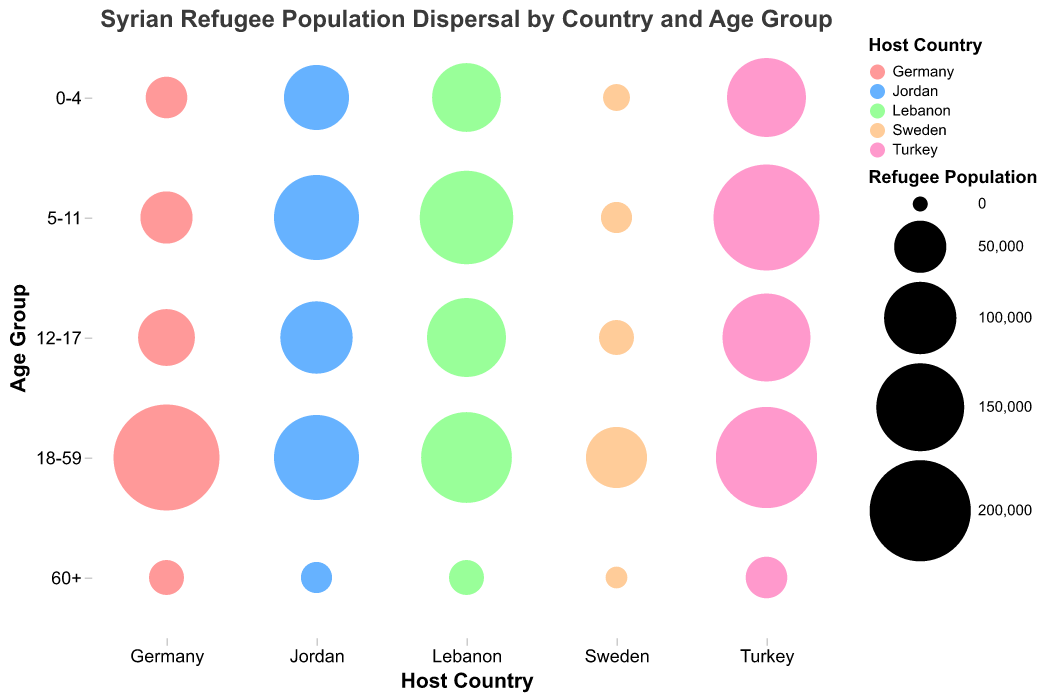What is the host country with the largest refugee population from Syria in the 18-59 age group? Observing the bubble chart, the largest bubble in the 18-59 age group is in Germany.
Answer: Germany Which age group has the smallest refugee population in Sweden? Referring to the smallest bubble in Sweden, the 60+ age group has the smallest population.
Answer: 60+ How many refugees in total are there in the age groups 0-4 and 5-11 in Jordan? Summing the populations of the 0-4 (80000) and 5-11 (140000) age groups in Jordan: 80000 + 140000 = 220000.
Answer: 220000 Compare the population of Syrian refugees aged 0-4 in Turkey and Lebanon. Which country has more? The bubble indicating the 0-4 age group in Turkey (120000) is larger than in Lebanon (90000).
Answer: Turkey Which country hosts the largest number of refugees aged 12-17? By identifying the largest bubble in the 12-17 age group, Turkey with 150000 has the most.
Answer: Turkey Which age group shows the highest refugee population in Lebanon? The largest bubble in Lebanon corresponds to the 5-11 age group with 170000 refugees.
Answer: 5-11 Is there more transparency in the bubbles representing Syrian refugees in Germany compared to those in Turkey? Bubbles in Germany have an opacity of 0.4, whereas those in Turkey have an opacity of 0.7. Hence, Germany's bubbles are more transparent.
Answer: Yes How does the refugee population aged 60+ in Germany compare to that in Jordan? Both Germany and Jordan have a bubble size indicating a population of 20000 and 15000 respectively in the 60+ age group, showing Germany has more.
Answer: Germany Compare the total refugee population of the 18-59 age group across Turkey and Lebanon. Which is higher? Adding the populations of the 18-59 age group: Turkey (200000) and Lebanon (160000). The total for Turkey is higher.
Answer: Turkey What is the total refugee population aged 60+ across all listed countries? Summing all the populations in the 60+ age group: 30000 (Turkey) + 20000 (Lebanon) + 15000 (Jordan) + 20000 (Germany) + 5000 (Sweden) = 90000.
Answer: 90000 